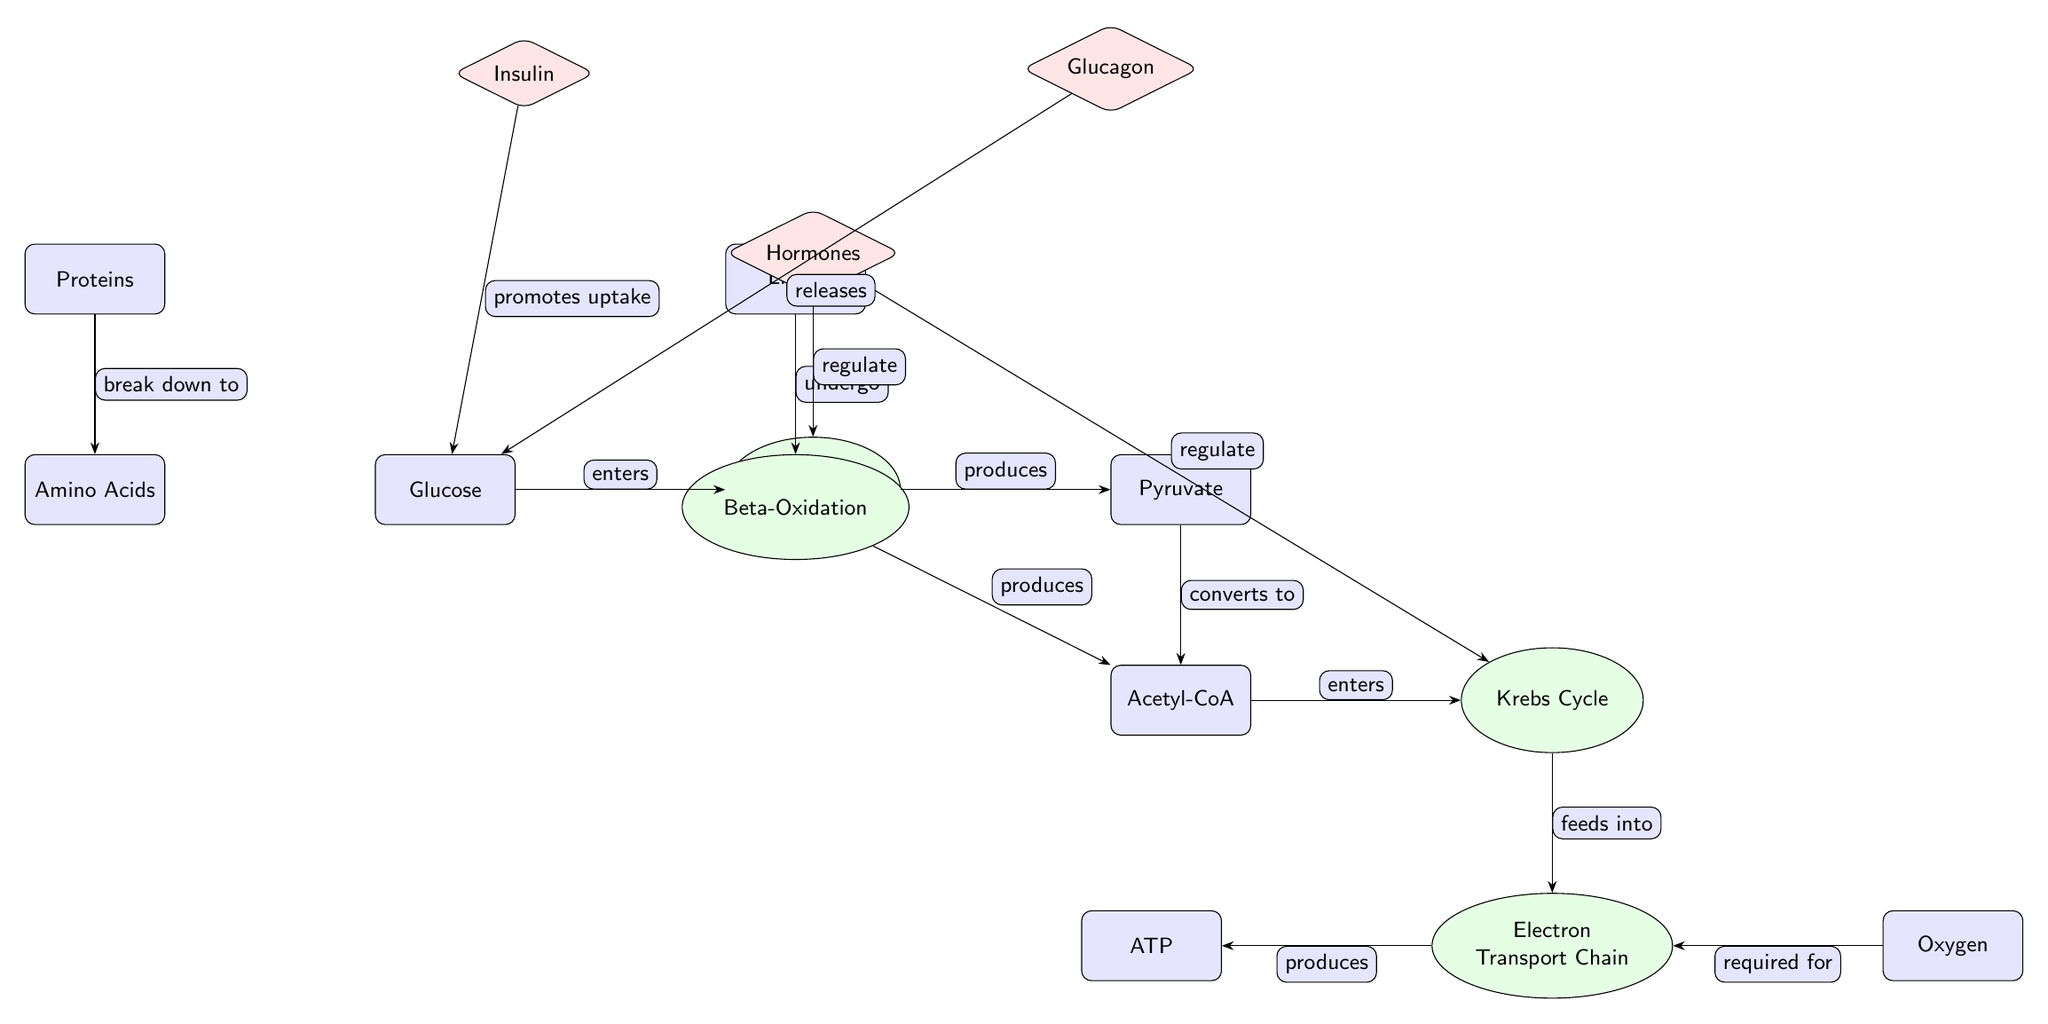What is the output of glycolysis? Glycolysis produces pyruvate as its output. By following the edge from glycolysis to pyruvate, we see that glycolysis processes glucose and yields pyruvate as the direct product.
Answer: Pyruvate How many hormones are indicated in the diagram? The diagram includes two hormones: insulin and glucagon, both shown above the glycolysis process and connected to the hormone node.
Answer: Two Which metabolite is produced by beta-oxidation? Beta-oxidation produces acetyl-CoA. This can be determined by tracing the flow from lipids to beta-oxidation, which then leads to acetyl-CoA.
Answer: Acetyl-CoA What is the relationship between glucose and insulin? Insulin promotes the uptake of glucose. This relationship is shown by the directed edge from insulin to the glucose process, indicating the effect of insulin.
Answer: Promotes uptake Which process comes after acetyl-CoA in the metabolic pathway? Acetyl-CoA enters the Krebs Cycle; the flow from acetyl-CoA clearly points to the Krebs Cycle as the next process in sequence.
Answer: Krebs Cycle Does oxygen play a role in the metabolic pathways shown in the diagram? Yes, oxygen is required for the electron transport chain. This is indicated by the connection from oxygen to the electron transport chain, highlighting its necessity for that process.
Answer: Required for What is the initial substrate for glycolysis? Glucose is the initial substrate for glycolysis, as indicated by the edge showing that glucose enters the glycolysis process.
Answer: Glucose Name a metabolite that results from protein breakdown. Amino acids are produced from the breakdown of proteins, as shown by the edge leading from proteins down to amino acids.
Answer: Amino Acids Which process leads to the production of ATP? The electron transport chain produces ATP. We can trace the flow from the electron transport chain to ATP to find this direct relationship.
Answer: Electron Transport Chain 